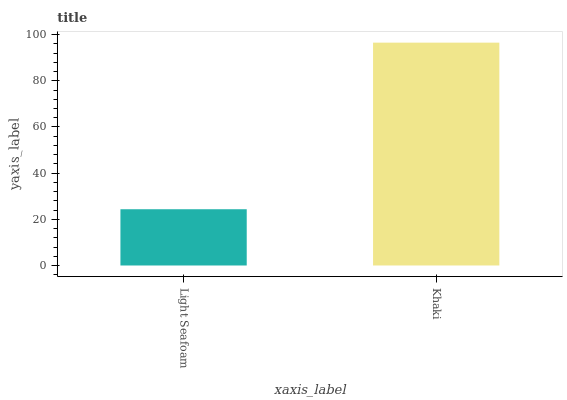Is Khaki the minimum?
Answer yes or no. No. Is Khaki greater than Light Seafoam?
Answer yes or no. Yes. Is Light Seafoam less than Khaki?
Answer yes or no. Yes. Is Light Seafoam greater than Khaki?
Answer yes or no. No. Is Khaki less than Light Seafoam?
Answer yes or no. No. Is Khaki the high median?
Answer yes or no. Yes. Is Light Seafoam the low median?
Answer yes or no. Yes. Is Light Seafoam the high median?
Answer yes or no. No. Is Khaki the low median?
Answer yes or no. No. 